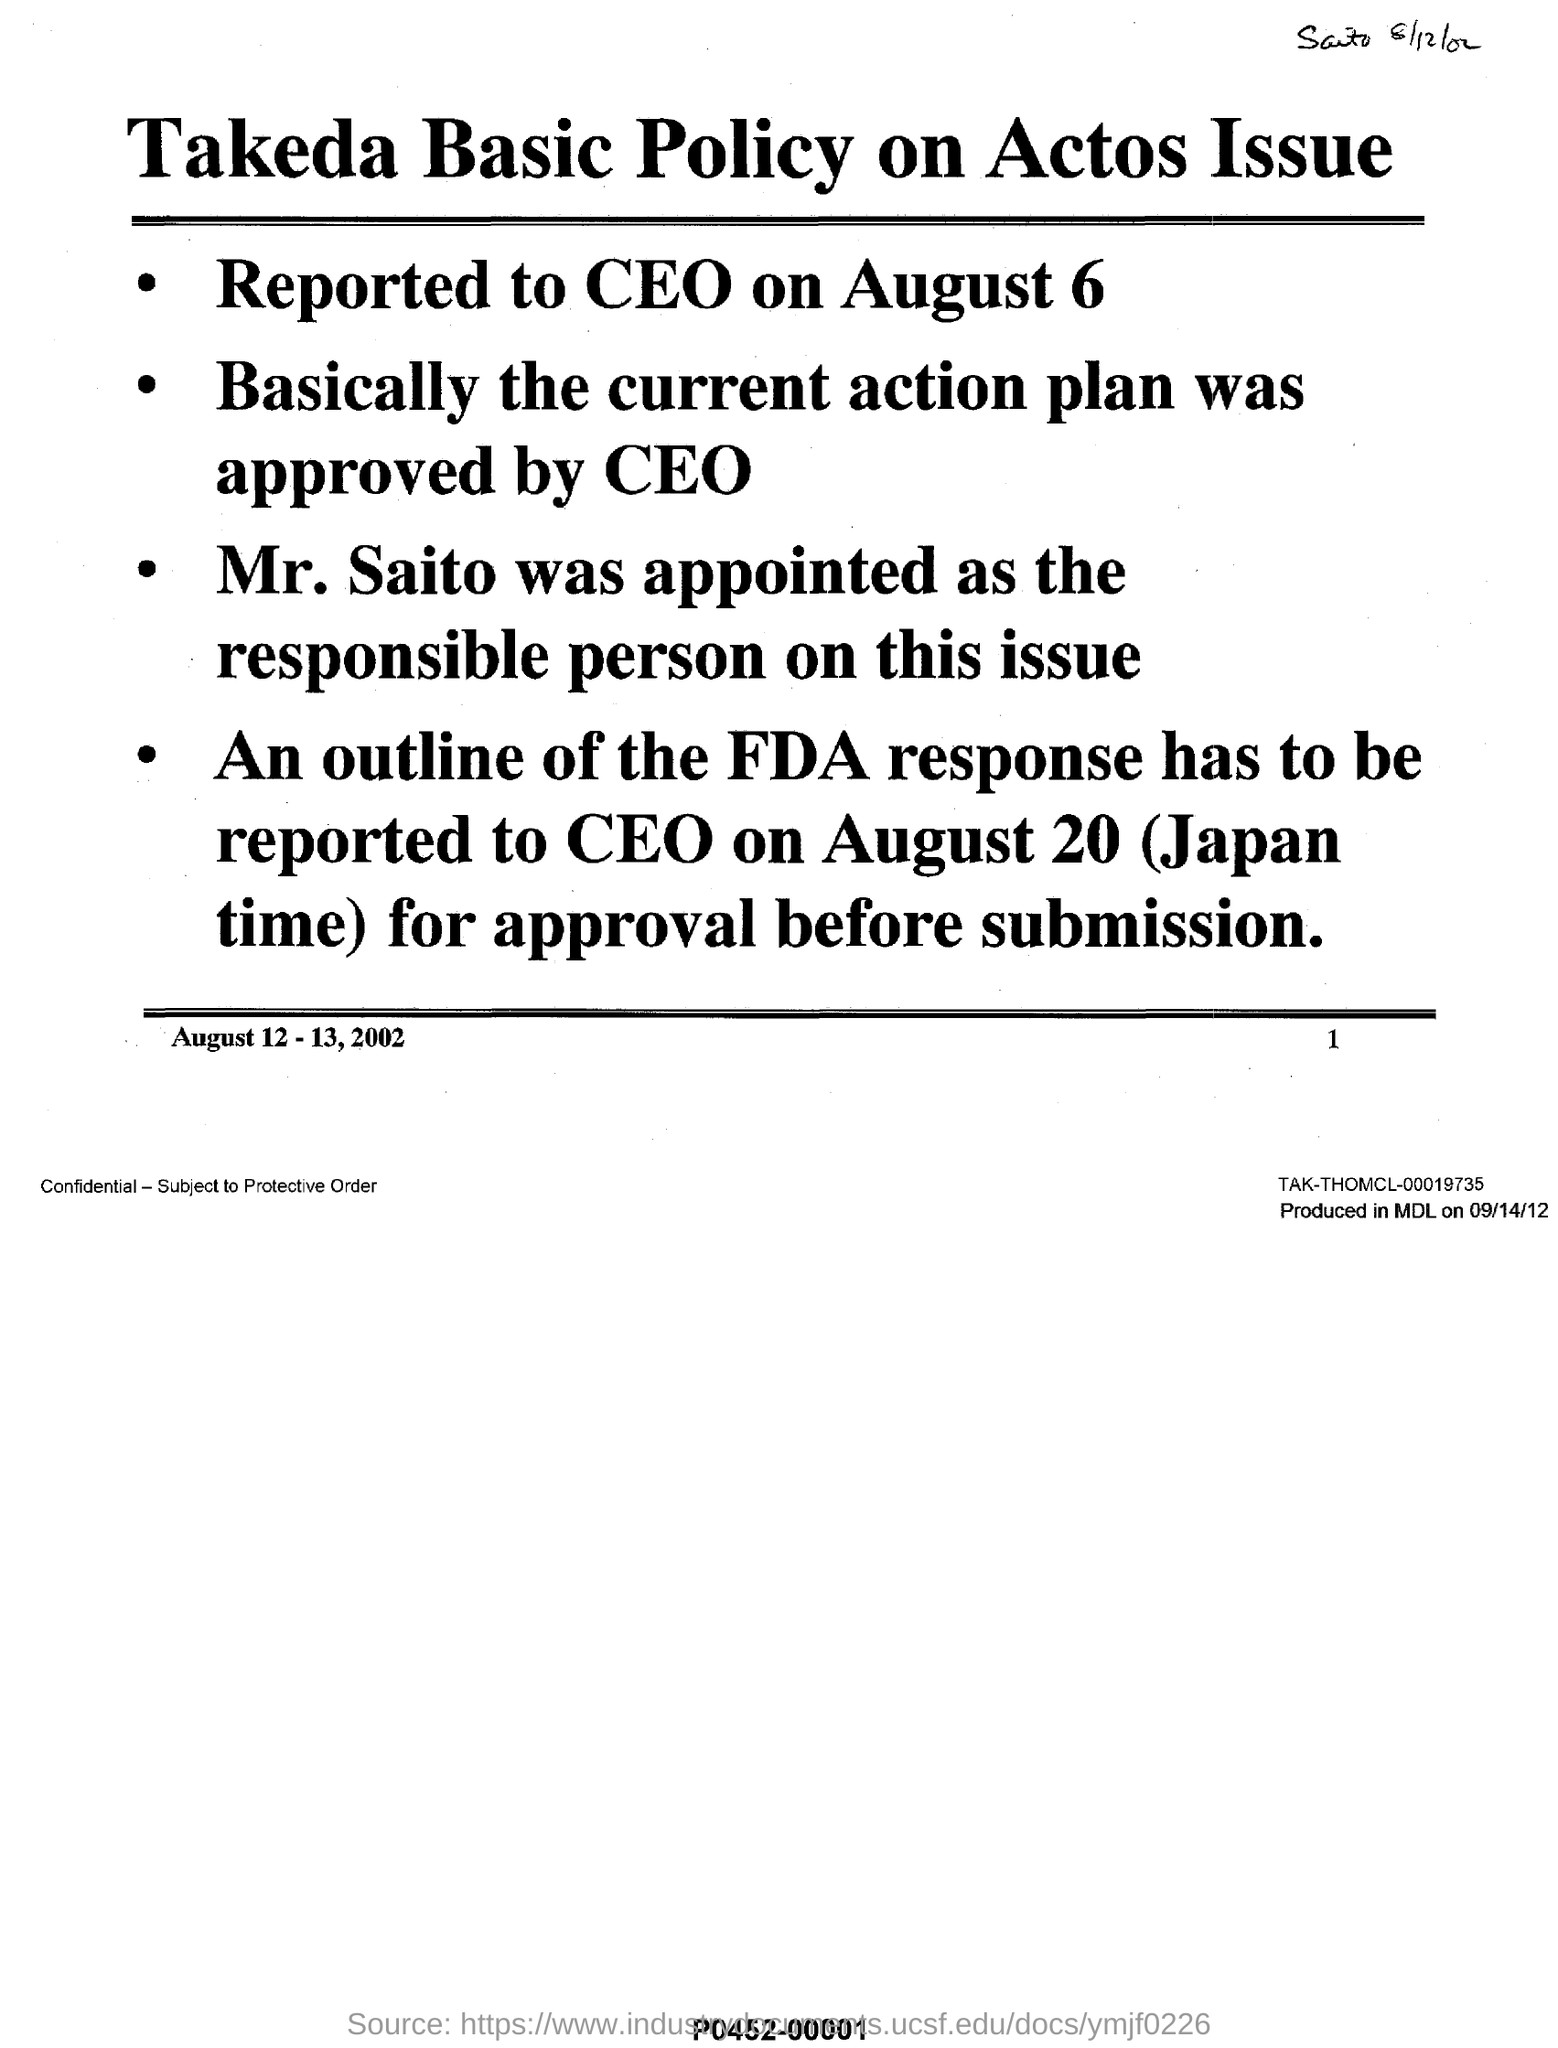Who appointed as the responsible person on this issue ?
Provide a succinct answer. MR. SAITO. Basically by whom the current action plan was approved ?
Make the answer very short. CEO. In which month and date it was reported to ceo ?
Offer a terse response. August 6. What has to be reported to ceo on august 20 (japan time) ?
Your response must be concise. An outline of the fda response. What is the name of the policy on actos issue ?
Offer a very short reply. Takeda basic policy. 